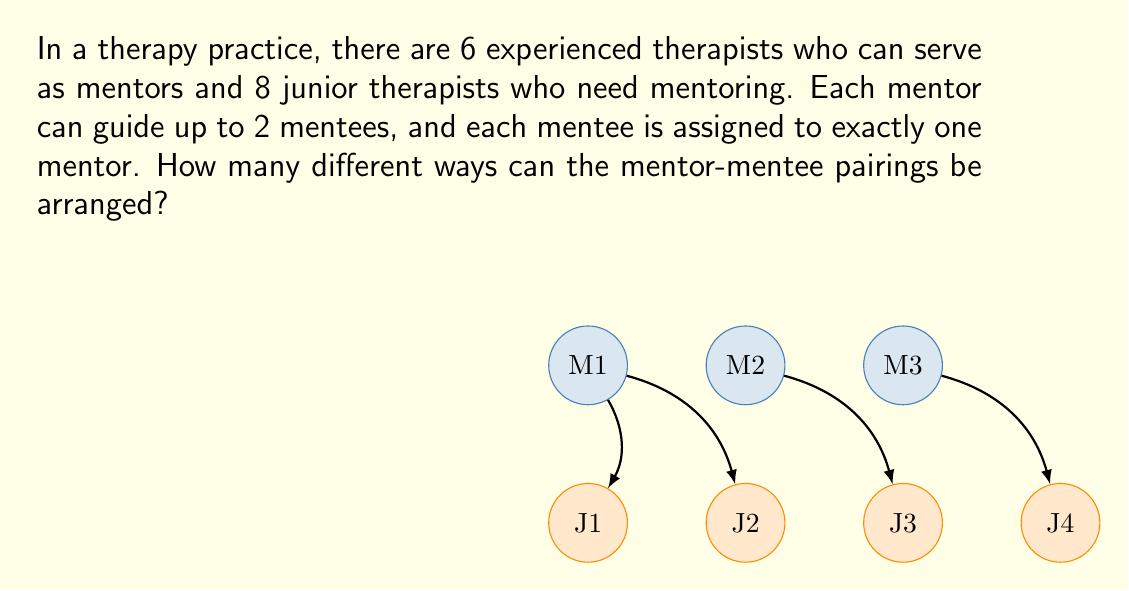Solve this math problem. Let's approach this step-by-step:

1) First, we need to choose which mentors will have 2 mentees and which will have 1 or 0. 
   This is equivalent to distributing 8 mentees into 6 groups (mentors), where each group can have 0, 1, or 2 elements.

2) This is a classic stars and bars problem. The number of ways to distribute 8 identical objects into 6 distinct groups is:
   $$\binom{8+6-1}{6-1} = \binom{13}{5}$$

3) Now, for each of these distributions, we need to arrange the mentees within their assigned groups.

4) For a distribution with $n_2$ mentors having 2 mentees, $n_1$ mentors having 1 mentee, and $n_0$ mentors having 0 mentees:
   - We have $\binom{8}{2,2,...,2,1,...,1}$ ways to choose which mentees go to which mentor
   - For each mentor with 2 mentees, there are 2! ways to arrange those mentees

5) So, for each distribution, we have:
   $$\binom{8}{2,2,...,2,1,...,1} \cdot (2!)^{n_2}$$ arrangements

6) The total number of arrangements is the sum of this quantity over all possible distributions.

7) We can calculate this using the following formula:
   $$\sum_{(n_2,n_1,n_0)} \binom{6}{n_2,n_1,n_0} \cdot \binom{8}{2n_2+n_1} \cdot (2!)^{n_2}$$
   where the sum is over all non-negative integer solutions to $n_2 + n_1 + n_0 = 6$ and $2n_2 + n_1 = 8$

8) Calculating this sum:
   $$(6,1,0): 1 \cdot 1 \cdot 64 = 64$$
   $$(5,3,0): 6 \cdot 56 \cdot 32 = 10752$$
   $$(4,4,0): 15 \cdot 70 \cdot 16 = 16800$$
   $$(4,3,1): 60 \cdot 70 \cdot 16 = 67200$$
   $$(3,5,0): 20 \cdot 56 \cdot 8 = 8960$$
   $$(3,4,1): 120 \cdot 56 \cdot 8 = 53760$$

9) The total sum is 157536.
Answer: 157536 